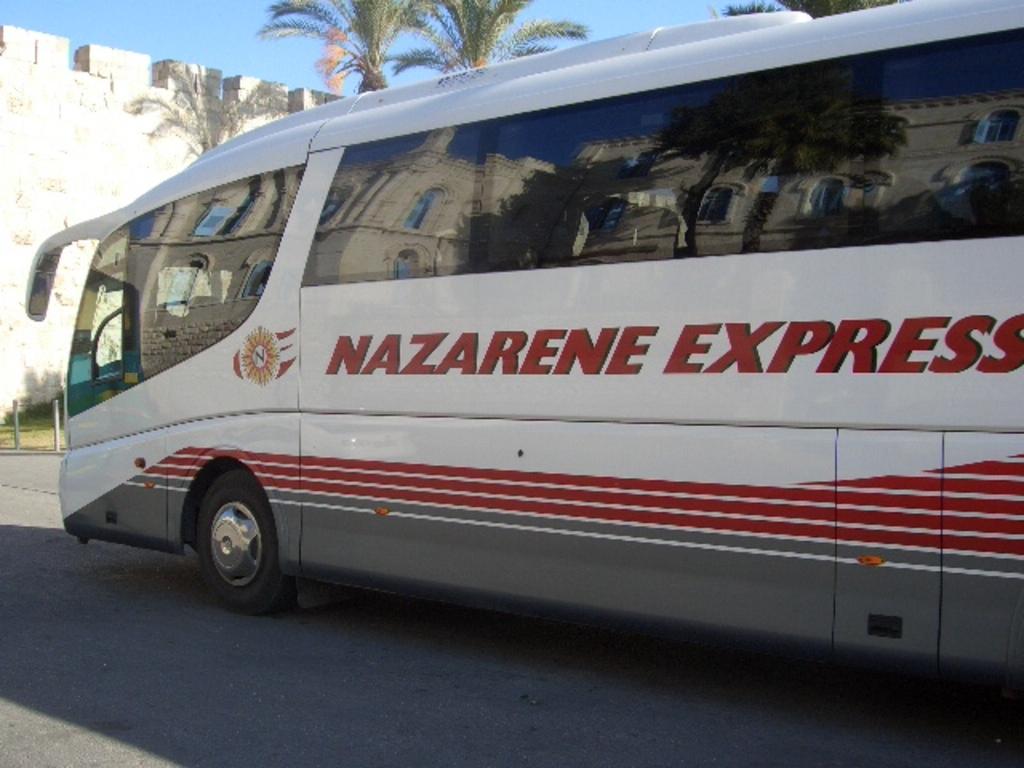What company is this?
Ensure brevity in your answer.  Nazarene express. 